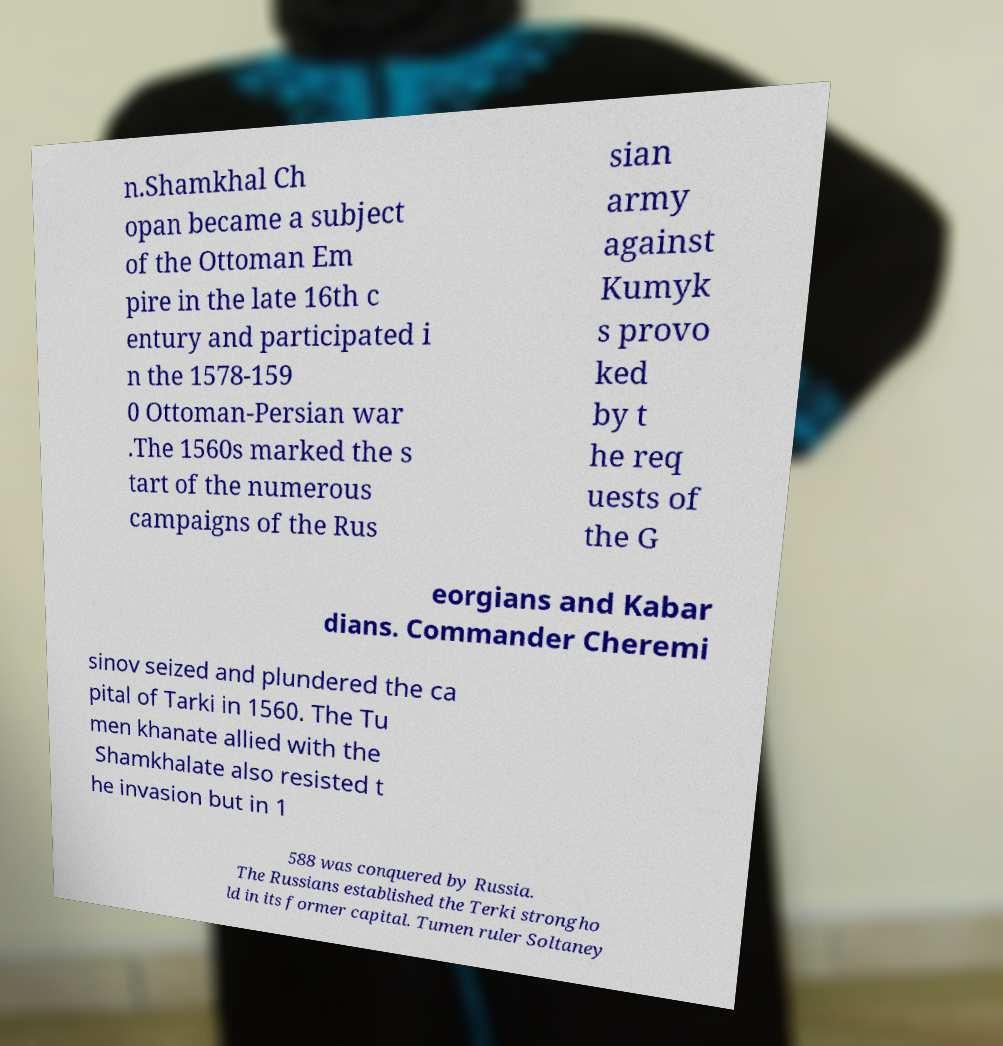For documentation purposes, I need the text within this image transcribed. Could you provide that? n.Shamkhal Ch opan became a subject of the Ottoman Em pire in the late 16th c entury and participated i n the 1578-159 0 Ottoman-Persian war .The 1560s marked the s tart of the numerous campaigns of the Rus sian army against Kumyk s provo ked by t he req uests of the G eorgians and Kabar dians. Commander Cheremi sinov seized and plundered the ca pital of Tarki in 1560. The Tu men khanate allied with the Shamkhalate also resisted t he invasion but in 1 588 was conquered by Russia. The Russians established the Terki strongho ld in its former capital. Tumen ruler Soltaney 